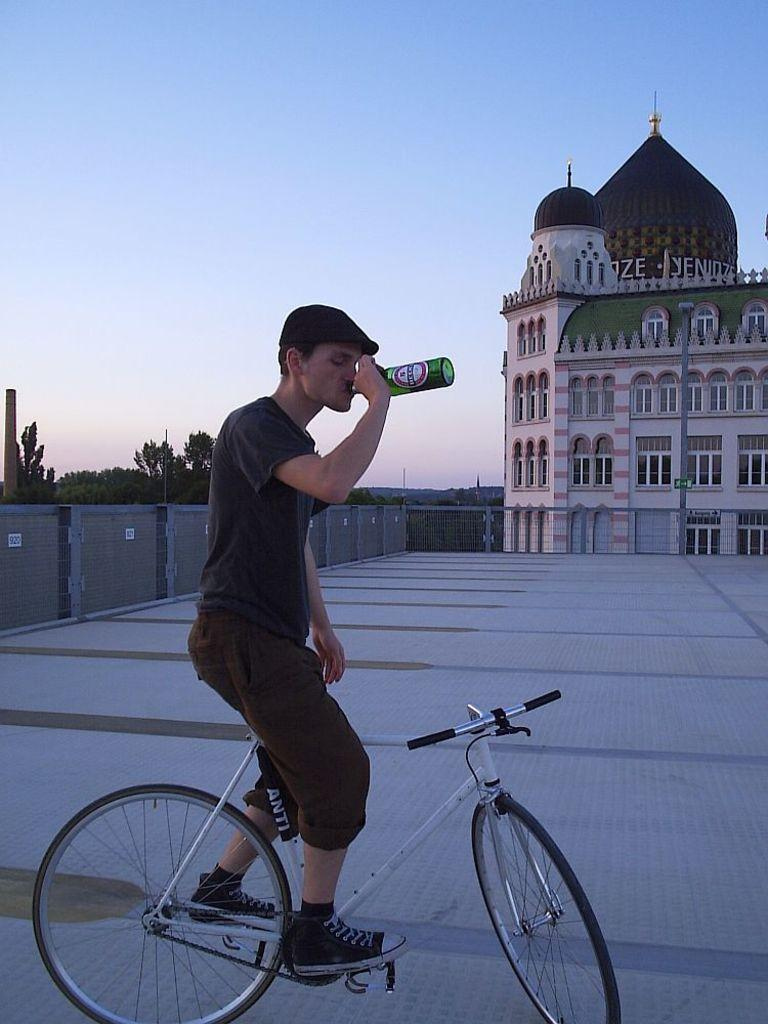What is the person in the image doing? The person is drinking. How is the person positioned while drinking? The person is standing on a bicycle. What can be seen in the background of the image? There are trees, sky, and a building visible in the background. What type of pen is the person using to write on their throat in the image? There is no pen or writing on the throat present in the image. 